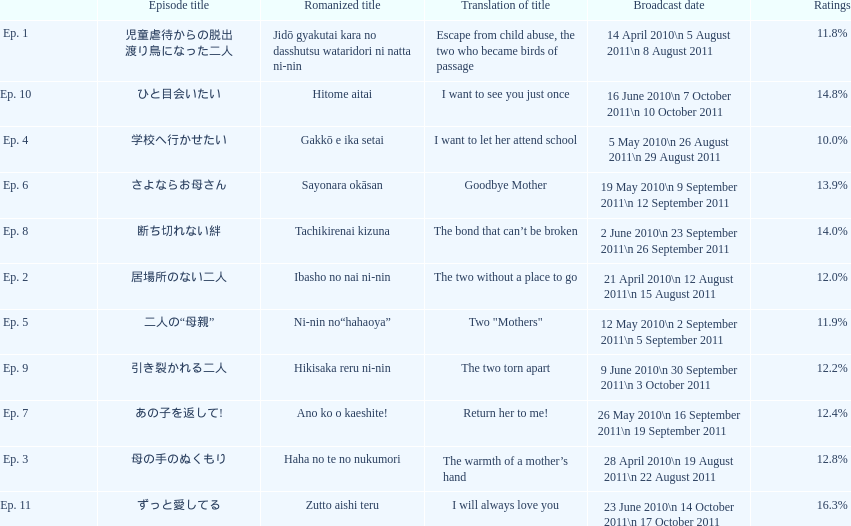How many episodes were broadcast in april 2010 in japan? 3. 